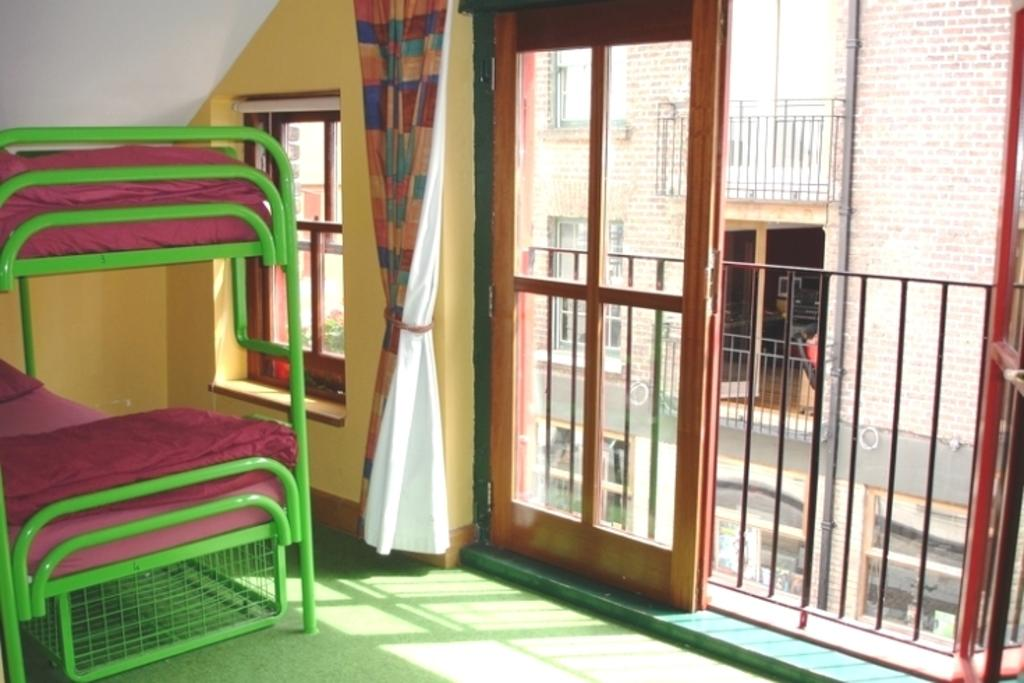What type of room is depicted in the image? The image appears to depict a bedroom. What is the main piece of furniture in the bedroom? There is a bed in the image. What is the purpose of the window in the bedroom? The window allows natural light to enter the room and provides a view of the outdoors. How is the window dressed in the image? There is a curtain associated with the window. How many doors are visible beside the curtain? There are two doors beside the curtain. What can be seen behind the doors in the image? There is another building visible behind the doors. What type of flame can be seen on the bed in the image? There is no flame present on the bed in the image. How many bananas are visible on the bed in the image? There are no bananas visible on the bed in the image. 